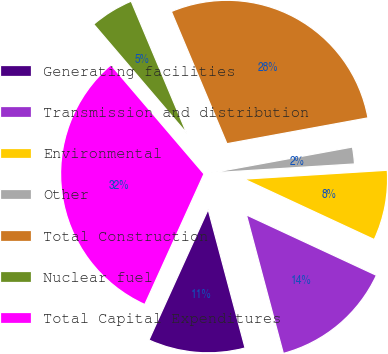Convert chart to OTSL. <chart><loc_0><loc_0><loc_500><loc_500><pie_chart><fcel>Generating facilities<fcel>Transmission and distribution<fcel>Environmental<fcel>Other<fcel>Total Construction<fcel>Nuclear fuel<fcel>Total Capital Expenditures<nl><fcel>10.92%<fcel>13.93%<fcel>7.91%<fcel>1.9%<fcel>28.45%<fcel>4.91%<fcel>31.98%<nl></chart> 